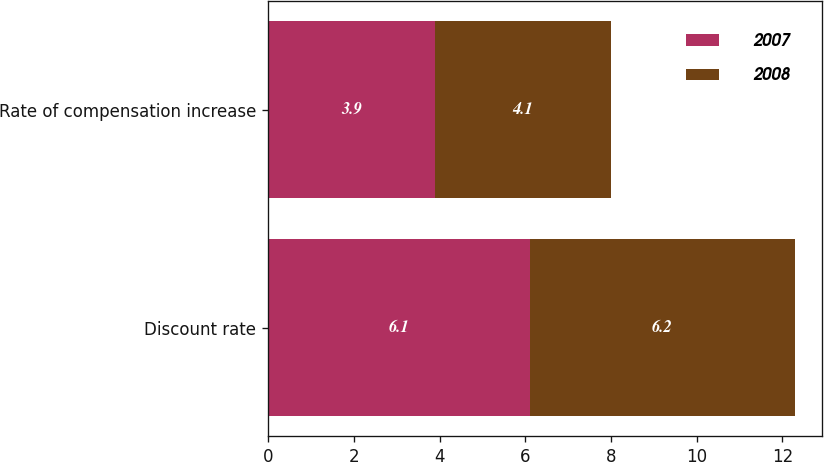Convert chart to OTSL. <chart><loc_0><loc_0><loc_500><loc_500><stacked_bar_chart><ecel><fcel>Discount rate<fcel>Rate of compensation increase<nl><fcel>2007<fcel>6.1<fcel>3.9<nl><fcel>2008<fcel>6.2<fcel>4.1<nl></chart> 